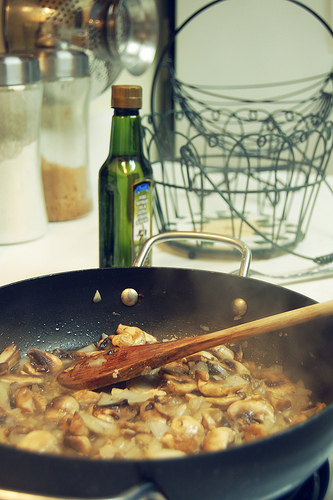<image>
Is the pan under the food? Yes. The pan is positioned underneath the food, with the food above it in the vertical space. 